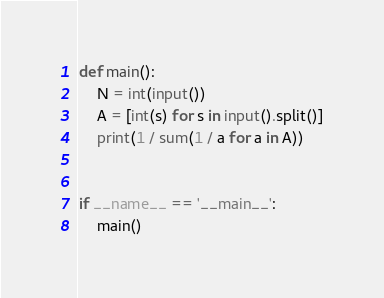Convert code to text. <code><loc_0><loc_0><loc_500><loc_500><_Python_>def main():
    N = int(input())
    A = [int(s) for s in input().split()]
    print(1 / sum(1 / a for a in A))


if __name__ == '__main__':
    main()
</code> 